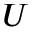<formula> <loc_0><loc_0><loc_500><loc_500>U</formula> 